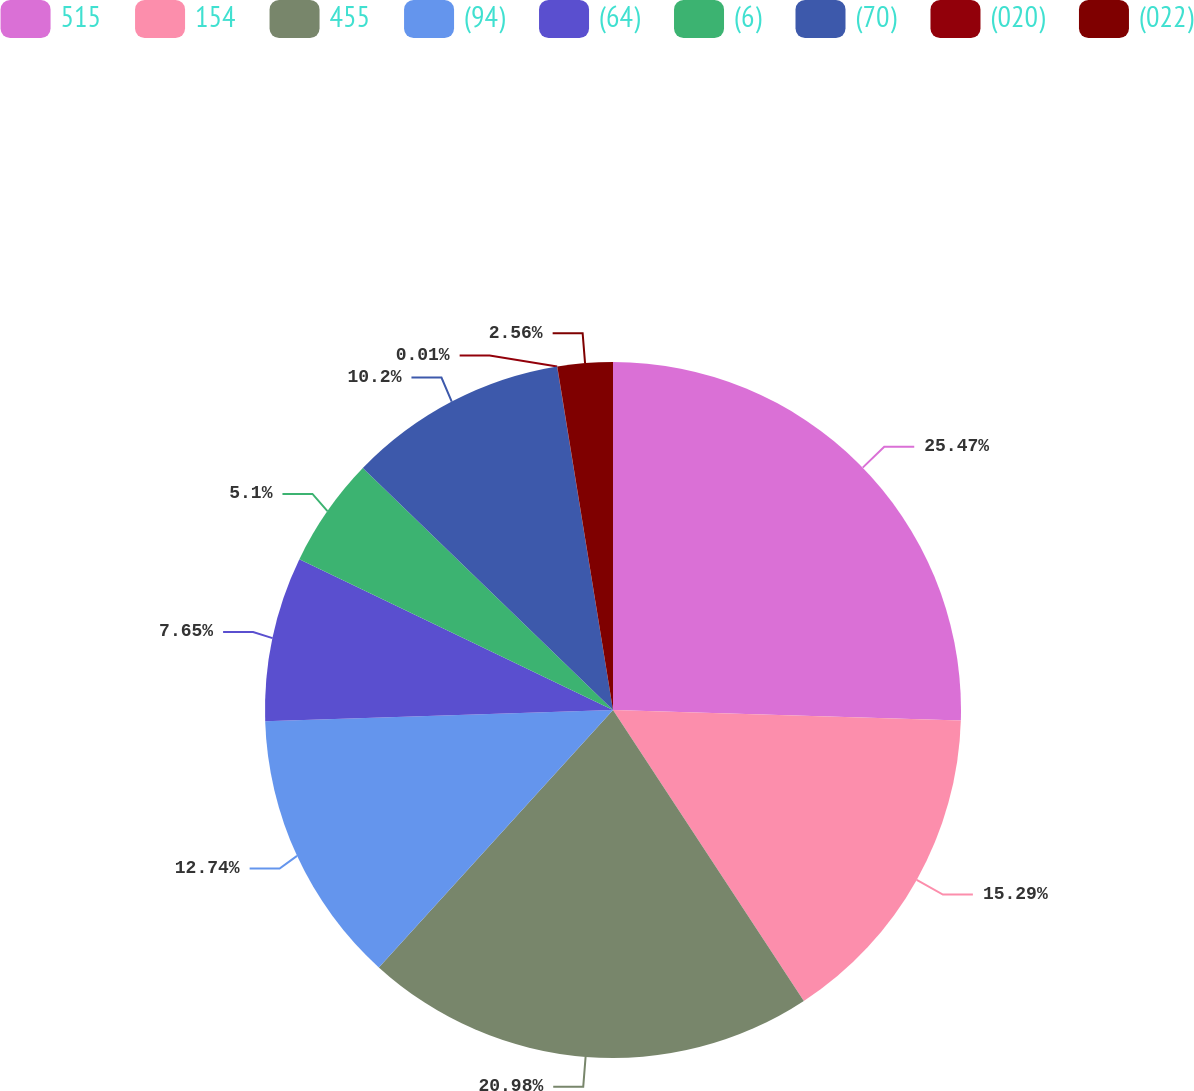Convert chart. <chart><loc_0><loc_0><loc_500><loc_500><pie_chart><fcel>515<fcel>154<fcel>455<fcel>(94)<fcel>(64)<fcel>(6)<fcel>(70)<fcel>(020)<fcel>(022)<nl><fcel>25.48%<fcel>15.29%<fcel>20.99%<fcel>12.74%<fcel>7.65%<fcel>5.1%<fcel>10.2%<fcel>0.01%<fcel>2.56%<nl></chart> 